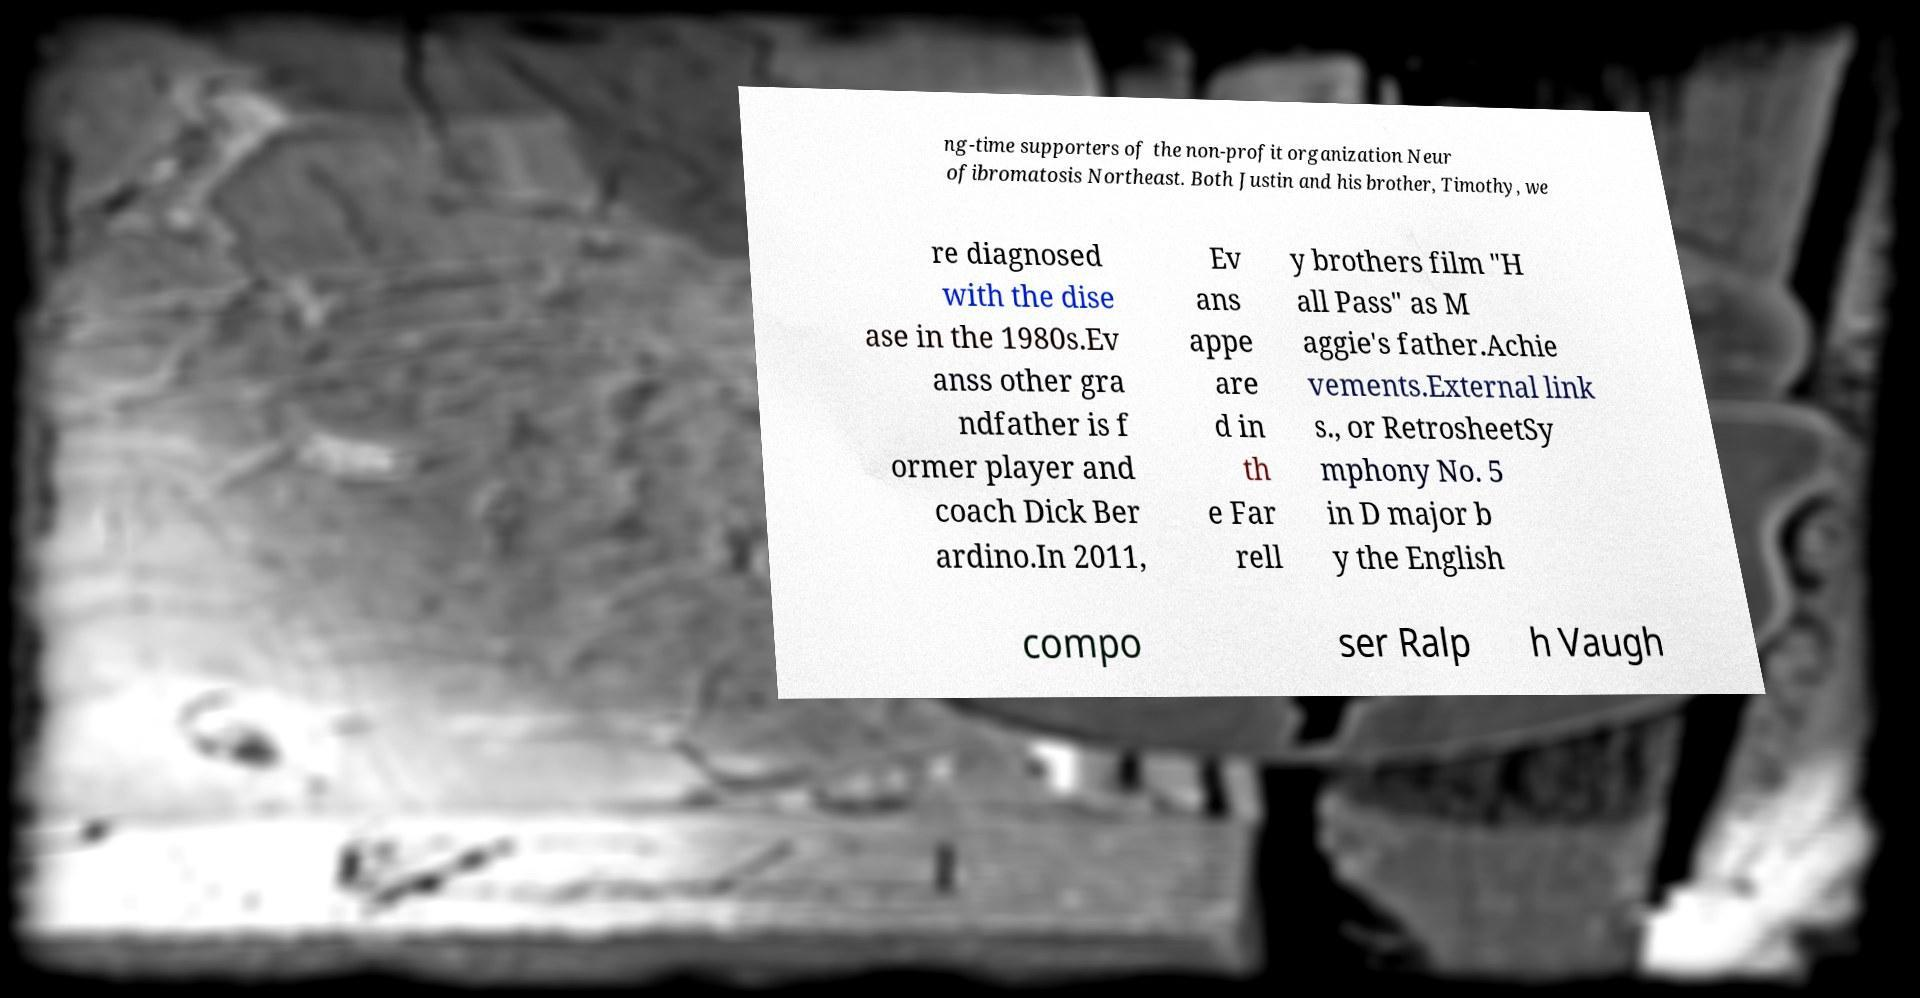Can you read and provide the text displayed in the image?This photo seems to have some interesting text. Can you extract and type it out for me? ng-time supporters of the non-profit organization Neur ofibromatosis Northeast. Both Justin and his brother, Timothy, we re diagnosed with the dise ase in the 1980s.Ev anss other gra ndfather is f ormer player and coach Dick Ber ardino.In 2011, Ev ans appe are d in th e Far rell y brothers film "H all Pass" as M aggie's father.Achie vements.External link s., or RetrosheetSy mphony No. 5 in D major b y the English compo ser Ralp h Vaugh 